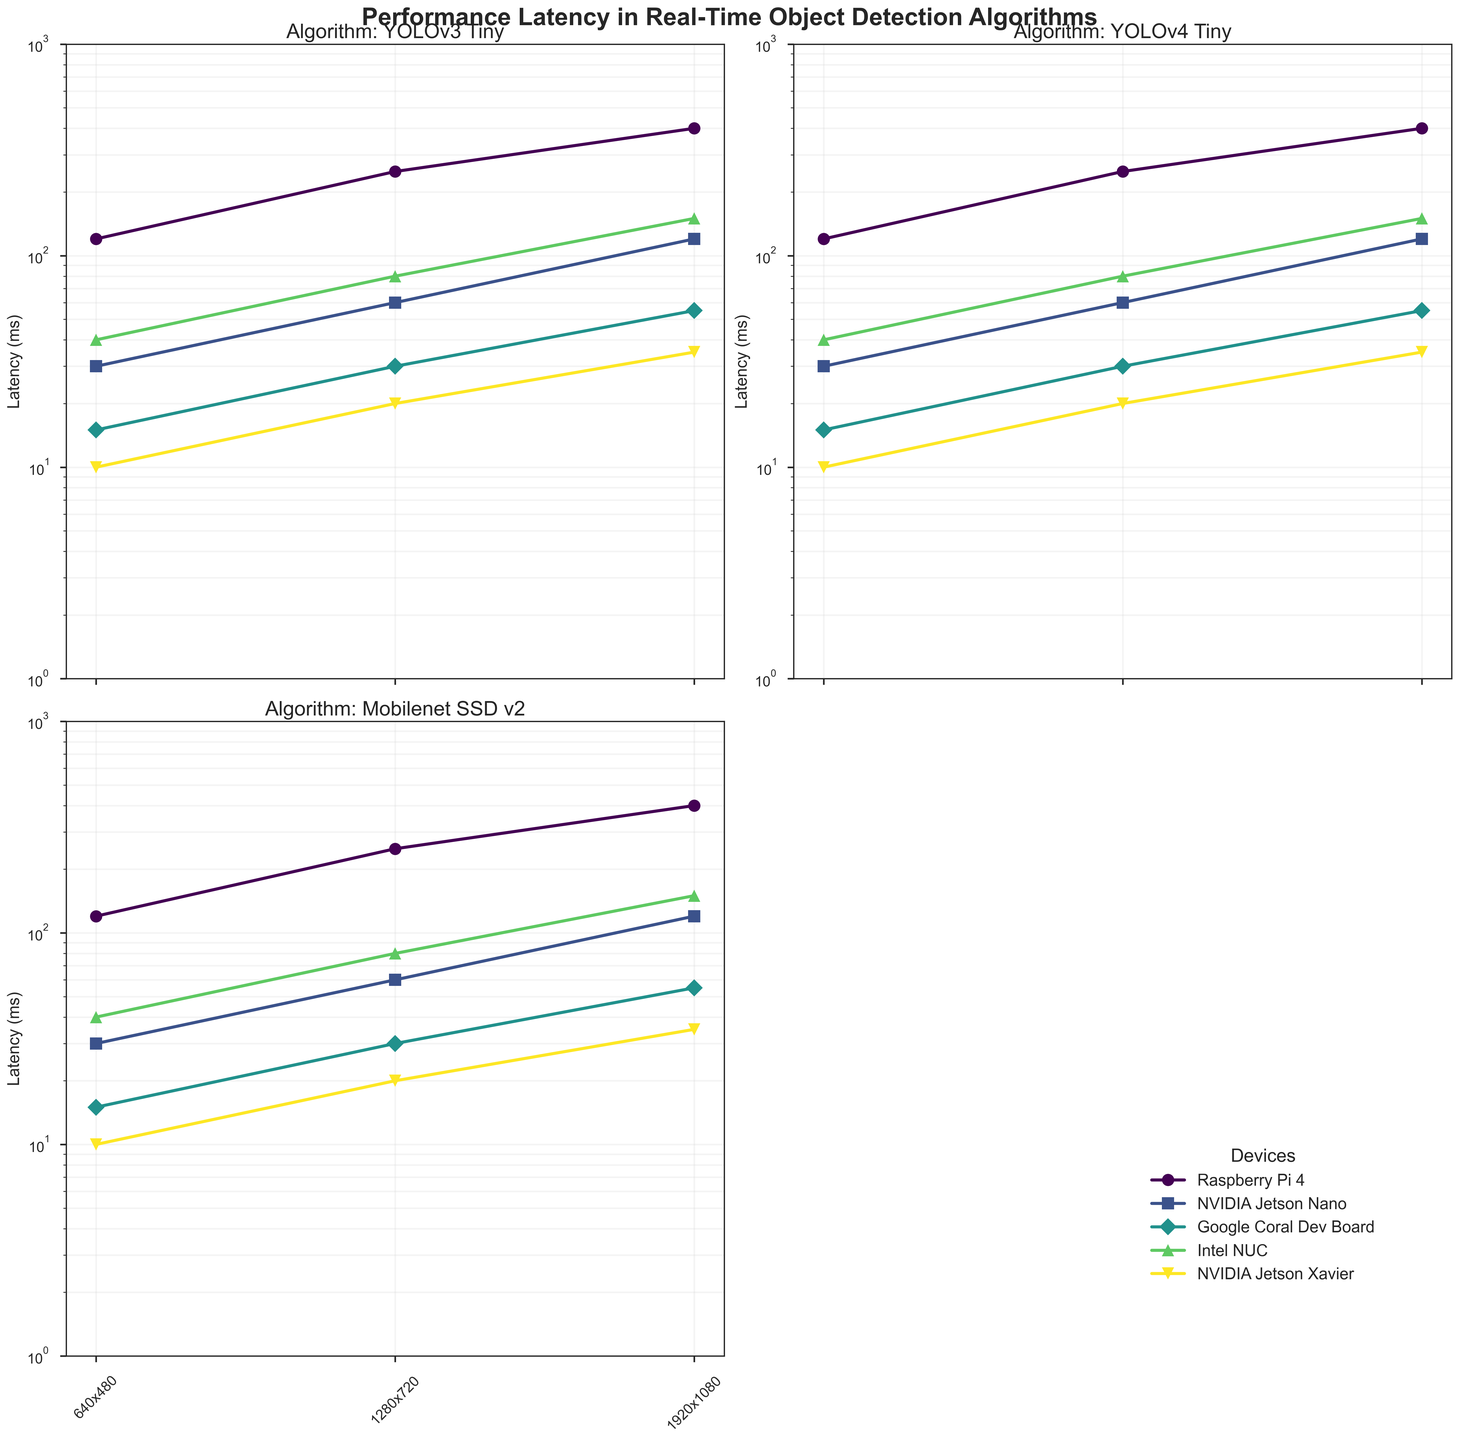What's the overall title of the figure? The overall title is usually found at the top of the plot above all subplots. Here, it is labeled as 'Performance Latency in Real-Time Object Detection Algorithms'.
Answer: Performance Latency in Real-Time Object Detection Algorithms What is the y-axis scale for the subplots? The y-axis scale can be identified by looking at the axis labels and tick marks. Here, it is clearly shown as 'Latency (ms)' with logarithmic spacing.
Answer: Logarithmic What is the resolution with the highest latency for the YOLOv3 Tiny algorithm on the Raspberry Pi 4? Find the subplot for YOLOv3 Tiny on the Raspberry Pi 4. The highest latency is at the largest resolution (1920x1080).
Answer: 1920x1080 Which device has the lowest latency for any algorithm, and what is that latency value? Look across all subplots and identify the smallest latency value. The Google Coral Dev Board running Mobilenet SSD v2 at 640x480 has the lowest latency, which is 15ms.
Answer: Google Coral Dev Board, 15 ms Compare the latency of YOLOv4 Tiny on the NVIDIA Jetson Nano to YOLOv4 on the NVIDIA Jetson Xavier at 1280x720 resolution. Which one is faster? Look at the two subplots for YOLOv4 Tiny on the Jetson Nano and YOLOv4 on the Jetson Xavier. YOLOv4 on the Xavier has a latency of 20ms, which is less than YOLOv4 Tiny's 60ms on the Jetson Nano.
Answer: YOLOv4 on the NVIDIA Jetson Xavier What is the average latency across all resolutions for the Mobilenet SSD v2 algorithm on the Google Coral Dev Board? Add up the latency values for the Google Coral Dev Board across all resolutions (15ms, 30ms, 55ms) and divide by 3. The total is 100ms, so the average is 100/3 = approximately 33.3ms.
Answer: Approximately 33.3ms Which algorithm-device pair has the highest increase in latency moving from 640x480 to 1920x1080 resolution? Calculate the differences in latency between 640x480 and 1920x1080 for each algorithm-device pair. The pair with the highest increase (YOLOv3 Tiny on Raspberry Pi 4) sees an increase of 400-120 = 280ms.
Answer: YOLOv3 Tiny on Raspberry Pi 4 For the Faster R-CNN algorithm on the Intel NUC, how does the latency change from 640x480 to 1280x720 resolution? Note the latency values for Faster R-CNN on Intel NUC at 640x480 (40ms) and at 1280x720 (80ms). The change is 80ms - 40ms = 40ms.
Answer: Increases by 40ms 